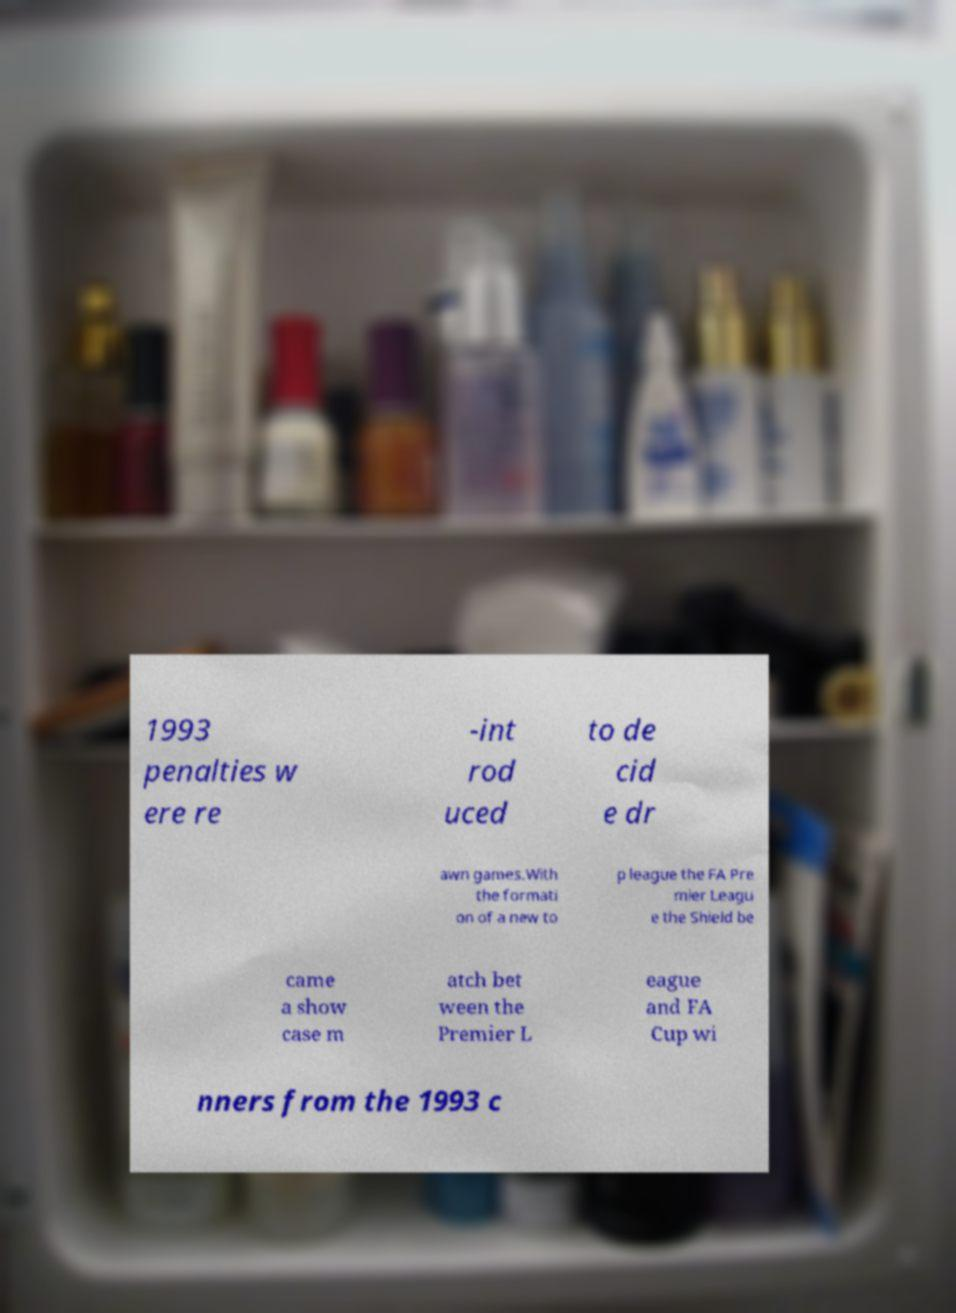What messages or text are displayed in this image? I need them in a readable, typed format. 1993 penalties w ere re -int rod uced to de cid e dr awn games.With the formati on of a new to p league the FA Pre mier Leagu e the Shield be came a show case m atch bet ween the Premier L eague and FA Cup wi nners from the 1993 c 